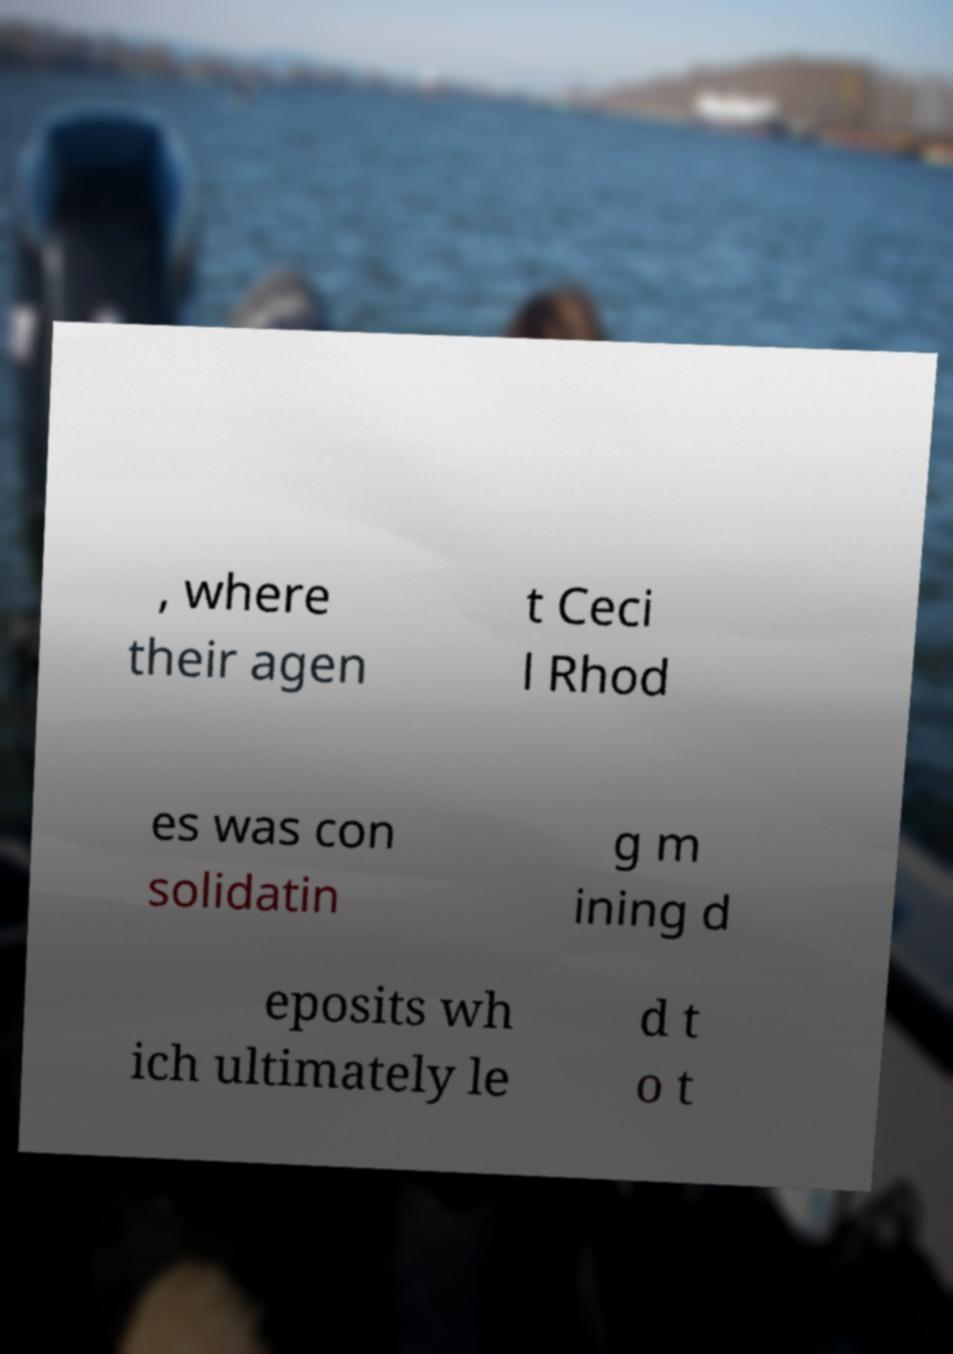Please read and relay the text visible in this image. What does it say? , where their agen t Ceci l Rhod es was con solidatin g m ining d eposits wh ich ultimately le d t o t 